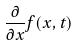<formula> <loc_0><loc_0><loc_500><loc_500>\frac { \partial } { \partial x } f ( x , t )</formula> 